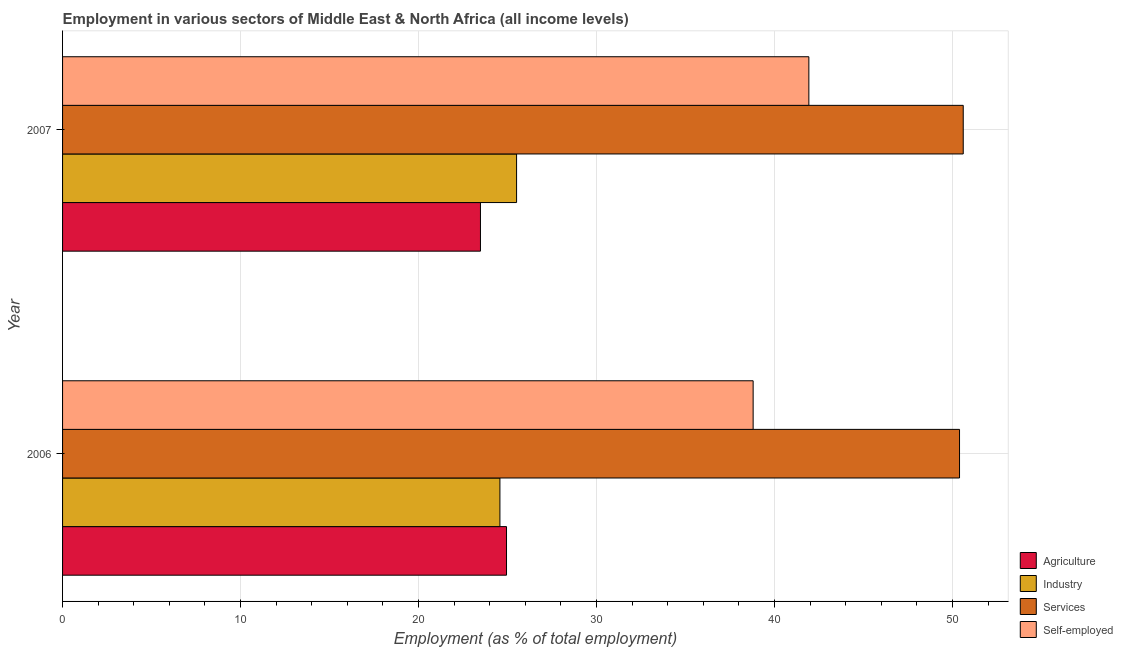How many different coloured bars are there?
Provide a short and direct response. 4. Are the number of bars per tick equal to the number of legend labels?
Give a very brief answer. Yes. Are the number of bars on each tick of the Y-axis equal?
Give a very brief answer. Yes. How many bars are there on the 2nd tick from the top?
Your answer should be compact. 4. What is the label of the 1st group of bars from the top?
Your response must be concise. 2007. In how many cases, is the number of bars for a given year not equal to the number of legend labels?
Offer a terse response. 0. What is the percentage of self employed workers in 2006?
Make the answer very short. 38.8. Across all years, what is the maximum percentage of workers in services?
Your answer should be very brief. 50.6. Across all years, what is the minimum percentage of workers in industry?
Your response must be concise. 24.57. In which year was the percentage of workers in industry maximum?
Ensure brevity in your answer.  2007. What is the total percentage of workers in industry in the graph?
Ensure brevity in your answer.  50.08. What is the difference between the percentage of workers in services in 2006 and that in 2007?
Provide a succinct answer. -0.21. What is the difference between the percentage of workers in industry in 2006 and the percentage of workers in services in 2007?
Provide a short and direct response. -26.03. What is the average percentage of workers in services per year?
Keep it short and to the point. 50.5. In the year 2006, what is the difference between the percentage of self employed workers and percentage of workers in agriculture?
Your response must be concise. 13.86. In how many years, is the percentage of workers in industry greater than 36 %?
Offer a very short reply. 0. What is the ratio of the percentage of workers in agriculture in 2006 to that in 2007?
Give a very brief answer. 1.06. Is the percentage of workers in agriculture in 2006 less than that in 2007?
Provide a succinct answer. No. Is the difference between the percentage of workers in services in 2006 and 2007 greater than the difference between the percentage of workers in industry in 2006 and 2007?
Provide a succinct answer. Yes. What does the 3rd bar from the top in 2006 represents?
Offer a very short reply. Industry. What does the 3rd bar from the bottom in 2007 represents?
Keep it short and to the point. Services. Is it the case that in every year, the sum of the percentage of workers in agriculture and percentage of workers in industry is greater than the percentage of workers in services?
Ensure brevity in your answer.  No. Are all the bars in the graph horizontal?
Make the answer very short. Yes. How many years are there in the graph?
Provide a short and direct response. 2. What is the difference between two consecutive major ticks on the X-axis?
Make the answer very short. 10. Does the graph contain any zero values?
Your answer should be very brief. No. What is the title of the graph?
Keep it short and to the point. Employment in various sectors of Middle East & North Africa (all income levels). What is the label or title of the X-axis?
Provide a succinct answer. Employment (as % of total employment). What is the Employment (as % of total employment) in Agriculture in 2006?
Give a very brief answer. 24.94. What is the Employment (as % of total employment) of Industry in 2006?
Ensure brevity in your answer.  24.57. What is the Employment (as % of total employment) of Services in 2006?
Your response must be concise. 50.39. What is the Employment (as % of total employment) of Self-employed in 2006?
Your answer should be compact. 38.8. What is the Employment (as % of total employment) of Agriculture in 2007?
Offer a very short reply. 23.48. What is the Employment (as % of total employment) of Industry in 2007?
Offer a very short reply. 25.51. What is the Employment (as % of total employment) in Services in 2007?
Provide a succinct answer. 50.6. What is the Employment (as % of total employment) in Self-employed in 2007?
Provide a short and direct response. 41.93. Across all years, what is the maximum Employment (as % of total employment) of Agriculture?
Make the answer very short. 24.94. Across all years, what is the maximum Employment (as % of total employment) in Industry?
Provide a short and direct response. 25.51. Across all years, what is the maximum Employment (as % of total employment) of Services?
Ensure brevity in your answer.  50.6. Across all years, what is the maximum Employment (as % of total employment) in Self-employed?
Offer a terse response. 41.93. Across all years, what is the minimum Employment (as % of total employment) in Agriculture?
Provide a succinct answer. 23.48. Across all years, what is the minimum Employment (as % of total employment) of Industry?
Offer a terse response. 24.57. Across all years, what is the minimum Employment (as % of total employment) of Services?
Provide a short and direct response. 50.39. Across all years, what is the minimum Employment (as % of total employment) of Self-employed?
Your answer should be very brief. 38.8. What is the total Employment (as % of total employment) of Agriculture in the graph?
Your answer should be compact. 48.42. What is the total Employment (as % of total employment) in Industry in the graph?
Your response must be concise. 50.08. What is the total Employment (as % of total employment) in Services in the graph?
Your response must be concise. 100.99. What is the total Employment (as % of total employment) of Self-employed in the graph?
Provide a succinct answer. 80.72. What is the difference between the Employment (as % of total employment) of Agriculture in 2006 and that in 2007?
Keep it short and to the point. 1.47. What is the difference between the Employment (as % of total employment) of Industry in 2006 and that in 2007?
Provide a short and direct response. -0.94. What is the difference between the Employment (as % of total employment) of Services in 2006 and that in 2007?
Provide a succinct answer. -0.21. What is the difference between the Employment (as % of total employment) of Self-employed in 2006 and that in 2007?
Your response must be concise. -3.13. What is the difference between the Employment (as % of total employment) of Agriculture in 2006 and the Employment (as % of total employment) of Industry in 2007?
Provide a succinct answer. -0.56. What is the difference between the Employment (as % of total employment) in Agriculture in 2006 and the Employment (as % of total employment) in Services in 2007?
Your answer should be very brief. -25.66. What is the difference between the Employment (as % of total employment) of Agriculture in 2006 and the Employment (as % of total employment) of Self-employed in 2007?
Offer a very short reply. -16.99. What is the difference between the Employment (as % of total employment) in Industry in 2006 and the Employment (as % of total employment) in Services in 2007?
Make the answer very short. -26.03. What is the difference between the Employment (as % of total employment) in Industry in 2006 and the Employment (as % of total employment) in Self-employed in 2007?
Your answer should be compact. -17.36. What is the difference between the Employment (as % of total employment) of Services in 2006 and the Employment (as % of total employment) of Self-employed in 2007?
Keep it short and to the point. 8.47. What is the average Employment (as % of total employment) of Agriculture per year?
Offer a very short reply. 24.21. What is the average Employment (as % of total employment) in Industry per year?
Provide a succinct answer. 25.04. What is the average Employment (as % of total employment) in Services per year?
Offer a very short reply. 50.5. What is the average Employment (as % of total employment) in Self-employed per year?
Offer a terse response. 40.36. In the year 2006, what is the difference between the Employment (as % of total employment) of Agriculture and Employment (as % of total employment) of Industry?
Offer a terse response. 0.37. In the year 2006, what is the difference between the Employment (as % of total employment) in Agriculture and Employment (as % of total employment) in Services?
Your answer should be very brief. -25.45. In the year 2006, what is the difference between the Employment (as % of total employment) in Agriculture and Employment (as % of total employment) in Self-employed?
Make the answer very short. -13.85. In the year 2006, what is the difference between the Employment (as % of total employment) of Industry and Employment (as % of total employment) of Services?
Offer a terse response. -25.82. In the year 2006, what is the difference between the Employment (as % of total employment) in Industry and Employment (as % of total employment) in Self-employed?
Your response must be concise. -14.23. In the year 2006, what is the difference between the Employment (as % of total employment) of Services and Employment (as % of total employment) of Self-employed?
Keep it short and to the point. 11.6. In the year 2007, what is the difference between the Employment (as % of total employment) of Agriculture and Employment (as % of total employment) of Industry?
Make the answer very short. -2.03. In the year 2007, what is the difference between the Employment (as % of total employment) in Agriculture and Employment (as % of total employment) in Services?
Your response must be concise. -27.12. In the year 2007, what is the difference between the Employment (as % of total employment) in Agriculture and Employment (as % of total employment) in Self-employed?
Provide a succinct answer. -18.45. In the year 2007, what is the difference between the Employment (as % of total employment) in Industry and Employment (as % of total employment) in Services?
Your answer should be very brief. -25.09. In the year 2007, what is the difference between the Employment (as % of total employment) of Industry and Employment (as % of total employment) of Self-employed?
Your answer should be very brief. -16.42. In the year 2007, what is the difference between the Employment (as % of total employment) in Services and Employment (as % of total employment) in Self-employed?
Make the answer very short. 8.67. What is the ratio of the Employment (as % of total employment) in Agriculture in 2006 to that in 2007?
Give a very brief answer. 1.06. What is the ratio of the Employment (as % of total employment) of Industry in 2006 to that in 2007?
Ensure brevity in your answer.  0.96. What is the ratio of the Employment (as % of total employment) in Self-employed in 2006 to that in 2007?
Provide a short and direct response. 0.93. What is the difference between the highest and the second highest Employment (as % of total employment) in Agriculture?
Provide a succinct answer. 1.47. What is the difference between the highest and the second highest Employment (as % of total employment) in Industry?
Give a very brief answer. 0.94. What is the difference between the highest and the second highest Employment (as % of total employment) of Services?
Give a very brief answer. 0.21. What is the difference between the highest and the second highest Employment (as % of total employment) of Self-employed?
Your response must be concise. 3.13. What is the difference between the highest and the lowest Employment (as % of total employment) of Agriculture?
Provide a succinct answer. 1.47. What is the difference between the highest and the lowest Employment (as % of total employment) in Industry?
Make the answer very short. 0.94. What is the difference between the highest and the lowest Employment (as % of total employment) of Services?
Keep it short and to the point. 0.21. What is the difference between the highest and the lowest Employment (as % of total employment) in Self-employed?
Keep it short and to the point. 3.13. 